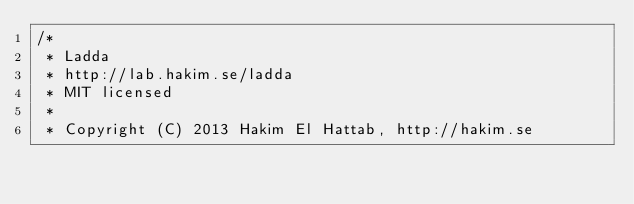Convert code to text. <code><loc_0><loc_0><loc_500><loc_500><_CSS_>/*
 * Ladda
 * http://lab.hakim.se/ladda
 * MIT licensed
 *
 * Copyright (C) 2013 Hakim El Hattab, http://hakim.se</code> 